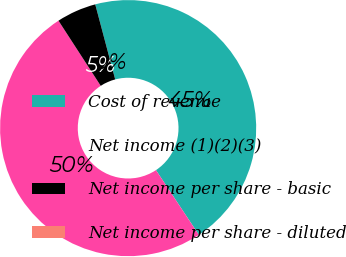Convert chart to OTSL. <chart><loc_0><loc_0><loc_500><loc_500><pie_chart><fcel>Cost of revenue<fcel>Net income (1)(2)(3)<fcel>Net income per share - basic<fcel>Net income per share - diluted<nl><fcel>44.83%<fcel>50.16%<fcel>5.02%<fcel>0.0%<nl></chart> 